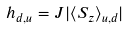Convert formula to latex. <formula><loc_0><loc_0><loc_500><loc_500>h _ { d , u } = J | \langle S _ { z } \rangle _ { u , d } |</formula> 